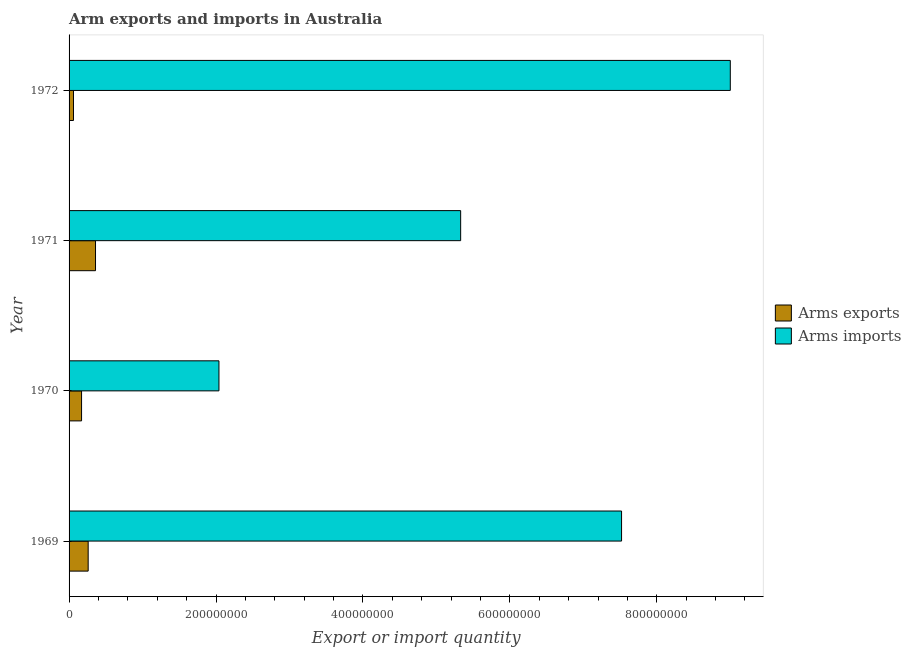How many bars are there on the 2nd tick from the top?
Your answer should be very brief. 2. How many bars are there on the 3rd tick from the bottom?
Provide a succinct answer. 2. What is the arms imports in 1972?
Ensure brevity in your answer.  9.00e+08. Across all years, what is the maximum arms exports?
Keep it short and to the point. 3.60e+07. Across all years, what is the minimum arms imports?
Offer a very short reply. 2.04e+08. In which year was the arms exports minimum?
Offer a very short reply. 1972. What is the total arms exports in the graph?
Make the answer very short. 8.50e+07. What is the difference between the arms exports in 1969 and that in 1971?
Ensure brevity in your answer.  -1.00e+07. What is the difference between the arms exports in 1971 and the arms imports in 1969?
Provide a succinct answer. -7.16e+08. What is the average arms imports per year?
Your response must be concise. 5.97e+08. In the year 1971, what is the difference between the arms exports and arms imports?
Your answer should be compact. -4.97e+08. What is the ratio of the arms imports in 1971 to that in 1972?
Offer a very short reply. 0.59. Is the arms exports in 1970 less than that in 1971?
Ensure brevity in your answer.  Yes. Is the difference between the arms imports in 1969 and 1970 greater than the difference between the arms exports in 1969 and 1970?
Provide a short and direct response. Yes. What is the difference between the highest and the second highest arms imports?
Keep it short and to the point. 1.48e+08. What is the difference between the highest and the lowest arms exports?
Ensure brevity in your answer.  3.00e+07. In how many years, is the arms imports greater than the average arms imports taken over all years?
Your answer should be compact. 2. Is the sum of the arms exports in 1969 and 1972 greater than the maximum arms imports across all years?
Offer a terse response. No. What does the 1st bar from the top in 1970 represents?
Make the answer very short. Arms imports. What does the 2nd bar from the bottom in 1971 represents?
Provide a succinct answer. Arms imports. Are all the bars in the graph horizontal?
Offer a terse response. Yes. How many years are there in the graph?
Keep it short and to the point. 4. What is the difference between two consecutive major ticks on the X-axis?
Provide a succinct answer. 2.00e+08. Are the values on the major ticks of X-axis written in scientific E-notation?
Keep it short and to the point. No. Does the graph contain any zero values?
Offer a very short reply. No. Does the graph contain grids?
Make the answer very short. No. What is the title of the graph?
Give a very brief answer. Arm exports and imports in Australia. Does "Under-5(female)" appear as one of the legend labels in the graph?
Your answer should be very brief. No. What is the label or title of the X-axis?
Your answer should be very brief. Export or import quantity. What is the label or title of the Y-axis?
Your answer should be compact. Year. What is the Export or import quantity of Arms exports in 1969?
Your answer should be very brief. 2.60e+07. What is the Export or import quantity in Arms imports in 1969?
Make the answer very short. 7.52e+08. What is the Export or import quantity of Arms exports in 1970?
Give a very brief answer. 1.70e+07. What is the Export or import quantity of Arms imports in 1970?
Offer a very short reply. 2.04e+08. What is the Export or import quantity of Arms exports in 1971?
Provide a succinct answer. 3.60e+07. What is the Export or import quantity of Arms imports in 1971?
Offer a very short reply. 5.33e+08. What is the Export or import quantity of Arms imports in 1972?
Offer a terse response. 9.00e+08. Across all years, what is the maximum Export or import quantity of Arms exports?
Keep it short and to the point. 3.60e+07. Across all years, what is the maximum Export or import quantity of Arms imports?
Make the answer very short. 9.00e+08. Across all years, what is the minimum Export or import quantity in Arms imports?
Your response must be concise. 2.04e+08. What is the total Export or import quantity in Arms exports in the graph?
Provide a short and direct response. 8.50e+07. What is the total Export or import quantity in Arms imports in the graph?
Give a very brief answer. 2.39e+09. What is the difference between the Export or import quantity of Arms exports in 1969 and that in 1970?
Your answer should be compact. 9.00e+06. What is the difference between the Export or import quantity in Arms imports in 1969 and that in 1970?
Keep it short and to the point. 5.48e+08. What is the difference between the Export or import quantity of Arms exports in 1969 and that in 1971?
Your answer should be very brief. -1.00e+07. What is the difference between the Export or import quantity in Arms imports in 1969 and that in 1971?
Provide a succinct answer. 2.19e+08. What is the difference between the Export or import quantity in Arms exports in 1969 and that in 1972?
Your answer should be compact. 2.00e+07. What is the difference between the Export or import quantity of Arms imports in 1969 and that in 1972?
Give a very brief answer. -1.48e+08. What is the difference between the Export or import quantity in Arms exports in 1970 and that in 1971?
Ensure brevity in your answer.  -1.90e+07. What is the difference between the Export or import quantity of Arms imports in 1970 and that in 1971?
Keep it short and to the point. -3.29e+08. What is the difference between the Export or import quantity in Arms exports in 1970 and that in 1972?
Ensure brevity in your answer.  1.10e+07. What is the difference between the Export or import quantity in Arms imports in 1970 and that in 1972?
Your answer should be compact. -6.96e+08. What is the difference between the Export or import quantity of Arms exports in 1971 and that in 1972?
Provide a short and direct response. 3.00e+07. What is the difference between the Export or import quantity of Arms imports in 1971 and that in 1972?
Give a very brief answer. -3.67e+08. What is the difference between the Export or import quantity of Arms exports in 1969 and the Export or import quantity of Arms imports in 1970?
Make the answer very short. -1.78e+08. What is the difference between the Export or import quantity of Arms exports in 1969 and the Export or import quantity of Arms imports in 1971?
Give a very brief answer. -5.07e+08. What is the difference between the Export or import quantity of Arms exports in 1969 and the Export or import quantity of Arms imports in 1972?
Your response must be concise. -8.74e+08. What is the difference between the Export or import quantity in Arms exports in 1970 and the Export or import quantity in Arms imports in 1971?
Give a very brief answer. -5.16e+08. What is the difference between the Export or import quantity of Arms exports in 1970 and the Export or import quantity of Arms imports in 1972?
Give a very brief answer. -8.83e+08. What is the difference between the Export or import quantity of Arms exports in 1971 and the Export or import quantity of Arms imports in 1972?
Provide a short and direct response. -8.64e+08. What is the average Export or import quantity of Arms exports per year?
Offer a very short reply. 2.12e+07. What is the average Export or import quantity in Arms imports per year?
Your answer should be compact. 5.97e+08. In the year 1969, what is the difference between the Export or import quantity in Arms exports and Export or import quantity in Arms imports?
Offer a terse response. -7.26e+08. In the year 1970, what is the difference between the Export or import quantity of Arms exports and Export or import quantity of Arms imports?
Give a very brief answer. -1.87e+08. In the year 1971, what is the difference between the Export or import quantity of Arms exports and Export or import quantity of Arms imports?
Provide a succinct answer. -4.97e+08. In the year 1972, what is the difference between the Export or import quantity in Arms exports and Export or import quantity in Arms imports?
Offer a very short reply. -8.94e+08. What is the ratio of the Export or import quantity of Arms exports in 1969 to that in 1970?
Your answer should be compact. 1.53. What is the ratio of the Export or import quantity of Arms imports in 1969 to that in 1970?
Offer a very short reply. 3.69. What is the ratio of the Export or import quantity in Arms exports in 1969 to that in 1971?
Offer a very short reply. 0.72. What is the ratio of the Export or import quantity in Arms imports in 1969 to that in 1971?
Ensure brevity in your answer.  1.41. What is the ratio of the Export or import quantity of Arms exports in 1969 to that in 1972?
Keep it short and to the point. 4.33. What is the ratio of the Export or import quantity in Arms imports in 1969 to that in 1972?
Keep it short and to the point. 0.84. What is the ratio of the Export or import quantity of Arms exports in 1970 to that in 1971?
Make the answer very short. 0.47. What is the ratio of the Export or import quantity in Arms imports in 1970 to that in 1971?
Keep it short and to the point. 0.38. What is the ratio of the Export or import quantity in Arms exports in 1970 to that in 1972?
Offer a very short reply. 2.83. What is the ratio of the Export or import quantity of Arms imports in 1970 to that in 1972?
Offer a terse response. 0.23. What is the ratio of the Export or import quantity of Arms exports in 1971 to that in 1972?
Keep it short and to the point. 6. What is the ratio of the Export or import quantity in Arms imports in 1971 to that in 1972?
Your answer should be compact. 0.59. What is the difference between the highest and the second highest Export or import quantity of Arms exports?
Keep it short and to the point. 1.00e+07. What is the difference between the highest and the second highest Export or import quantity in Arms imports?
Offer a very short reply. 1.48e+08. What is the difference between the highest and the lowest Export or import quantity in Arms exports?
Offer a terse response. 3.00e+07. What is the difference between the highest and the lowest Export or import quantity of Arms imports?
Offer a very short reply. 6.96e+08. 